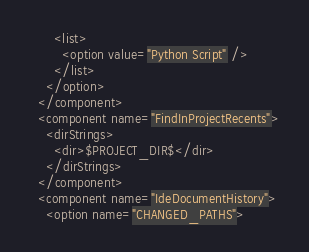<code> <loc_0><loc_0><loc_500><loc_500><_XML_>      <list>
        <option value="Python Script" />
      </list>
    </option>
  </component>
  <component name="FindInProjectRecents">
    <dirStrings>
      <dir>$PROJECT_DIR$</dir>
    </dirStrings>
  </component>
  <component name="IdeDocumentHistory">
    <option name="CHANGED_PATHS"></code> 